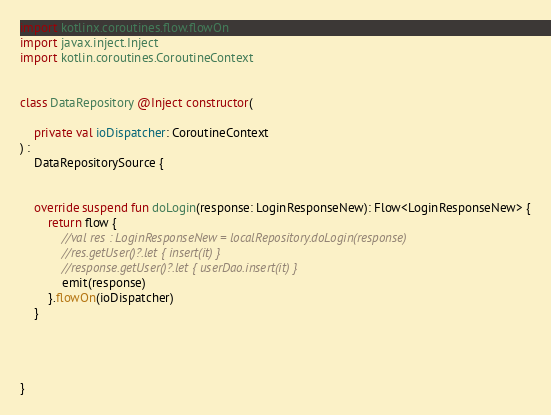<code> <loc_0><loc_0><loc_500><loc_500><_Kotlin_>import kotlinx.coroutines.flow.flowOn
import javax.inject.Inject
import kotlin.coroutines.CoroutineContext


class DataRepository @Inject constructor(

    private val ioDispatcher: CoroutineContext
) :
    DataRepositorySource {


    override suspend fun doLogin(response: LoginResponseNew): Flow<LoginResponseNew> {
        return flow {
            //val res : LoginResponseNew = localRepository.doLogin(response)
            //res.getUser()?.let { insert(it) }
            //response.getUser()?.let { userDao.insert(it) }
            emit(response)
        }.flowOn(ioDispatcher)
    }




}
</code> 